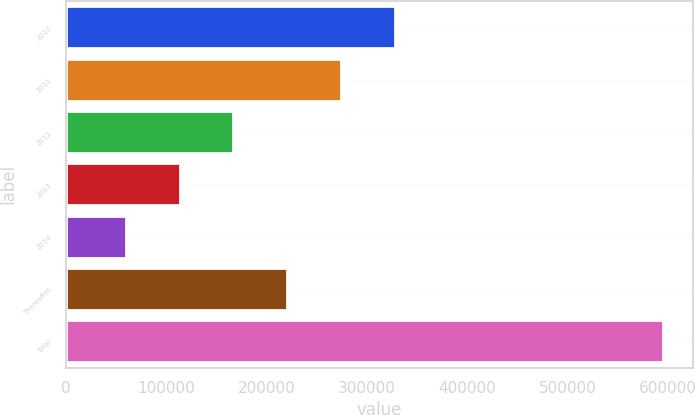<chart> <loc_0><loc_0><loc_500><loc_500><bar_chart><fcel>2010<fcel>2011<fcel>2012<fcel>2013<fcel>2014<fcel>Thereafter<fcel>Total<nl><fcel>327517<fcel>273966<fcel>166863<fcel>113312<fcel>59761<fcel>220415<fcel>595273<nl></chart> 